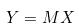<formula> <loc_0><loc_0><loc_500><loc_500>Y = M X</formula> 